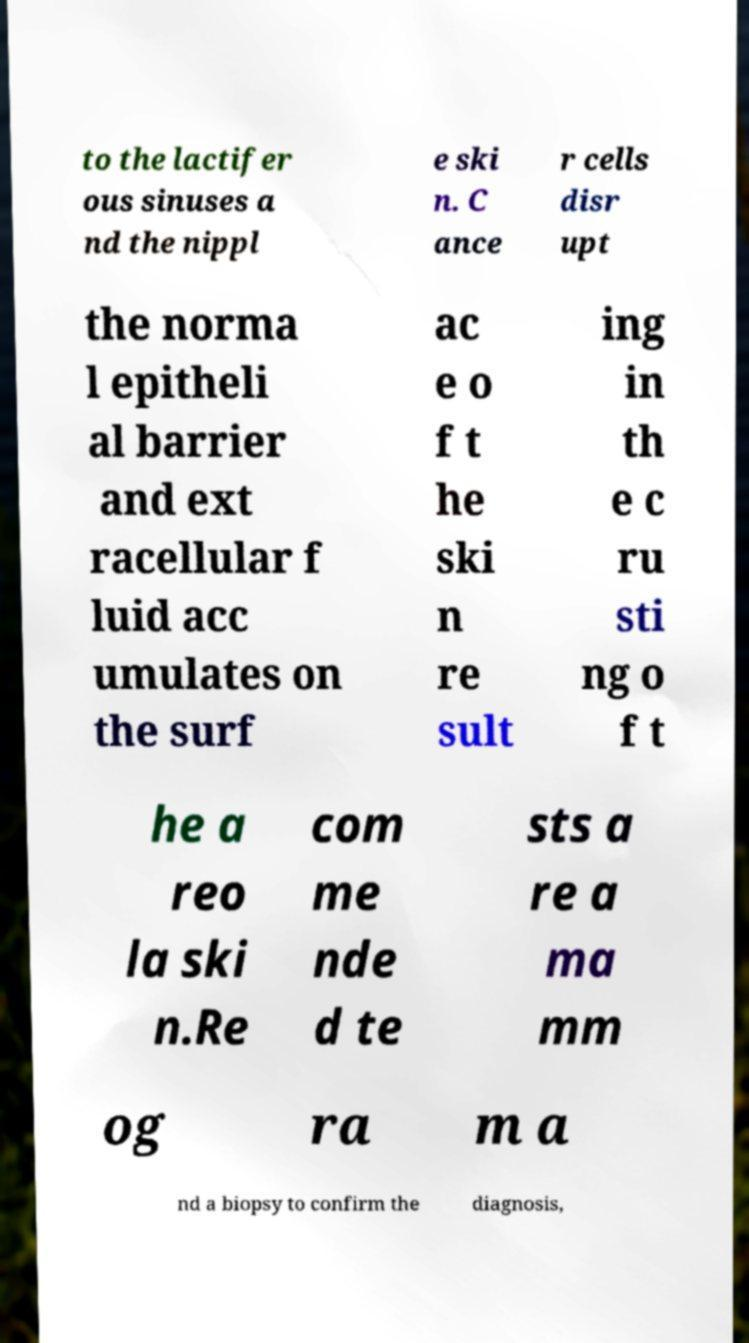Can you read and provide the text displayed in the image?This photo seems to have some interesting text. Can you extract and type it out for me? to the lactifer ous sinuses a nd the nippl e ski n. C ance r cells disr upt the norma l epitheli al barrier and ext racellular f luid acc umulates on the surf ac e o f t he ski n re sult ing in th e c ru sti ng o f t he a reo la ski n.Re com me nde d te sts a re a ma mm og ra m a nd a biopsy to confirm the diagnosis, 